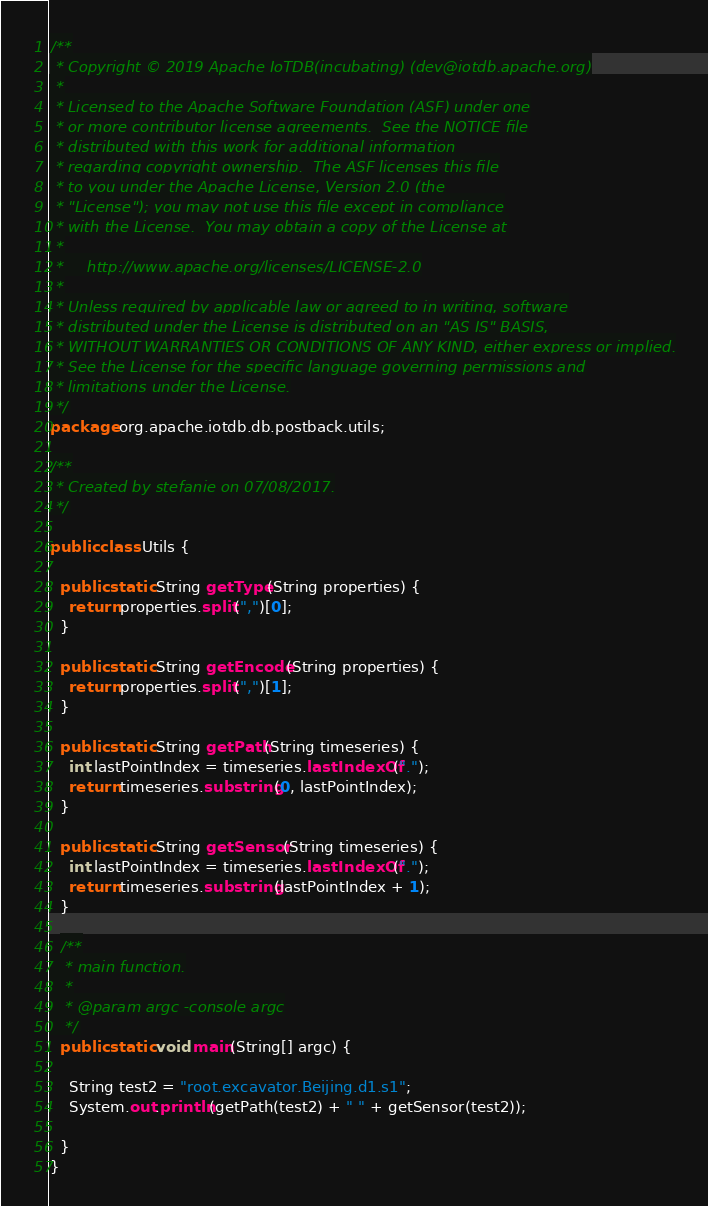<code> <loc_0><loc_0><loc_500><loc_500><_Java_>/**
 * Copyright © 2019 Apache IoTDB(incubating) (dev@iotdb.apache.org)
 *
 * Licensed to the Apache Software Foundation (ASF) under one
 * or more contributor license agreements.  See the NOTICE file
 * distributed with this work for additional information
 * regarding copyright ownership.  The ASF licenses this file
 * to you under the Apache License, Version 2.0 (the
 * "License"); you may not use this file except in compliance
 * with the License.  You may obtain a copy of the License at
 *
 *     http://www.apache.org/licenses/LICENSE-2.0
 *
 * Unless required by applicable law or agreed to in writing, software
 * distributed under the License is distributed on an "AS IS" BASIS,
 * WITHOUT WARRANTIES OR CONDITIONS OF ANY KIND, either express or implied.
 * See the License for the specific language governing permissions and
 * limitations under the License.
 */
package org.apache.iotdb.db.postback.utils;

/**
 * Created by stefanie on 07/08/2017.
 */

public class Utils {

  public static String getType(String properties) {
    return properties.split(",")[0];
  }

  public static String getEncode(String properties) {
    return properties.split(",")[1];
  }

  public static String getPath(String timeseries) {
    int lastPointIndex = timeseries.lastIndexOf(".");
    return timeseries.substring(0, lastPointIndex);
  }

  public static String getSensor(String timeseries) {
    int lastPointIndex = timeseries.lastIndexOf(".");
    return timeseries.substring(lastPointIndex + 1);
  }

  /**
   * main function.
   *
   * @param argc -console argc
   */
  public static void main(String[] argc) {

    String test2 = "root.excavator.Beijing.d1.s1";
    System.out.println(getPath(test2) + " " + getSensor(test2));

  }
}
</code> 